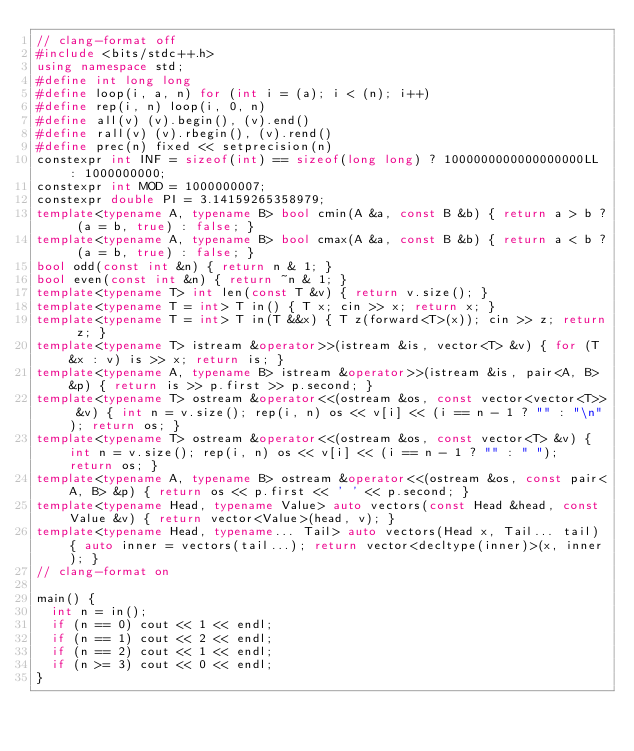Convert code to text. <code><loc_0><loc_0><loc_500><loc_500><_C++_>// clang-format off
#include <bits/stdc++.h>
using namespace std;
#define int long long
#define loop(i, a, n) for (int i = (a); i < (n); i++)
#define rep(i, n) loop(i, 0, n)
#define all(v) (v).begin(), (v).end()
#define rall(v) (v).rbegin(), (v).rend()
#define prec(n) fixed << setprecision(n)
constexpr int INF = sizeof(int) == sizeof(long long) ? 1000000000000000000LL : 1000000000;
constexpr int MOD = 1000000007;
constexpr double PI = 3.14159265358979;
template<typename A, typename B> bool cmin(A &a, const B &b) { return a > b ? (a = b, true) : false; }
template<typename A, typename B> bool cmax(A &a, const B &b) { return a < b ? (a = b, true) : false; }
bool odd(const int &n) { return n & 1; }
bool even(const int &n) { return ~n & 1; }
template<typename T> int len(const T &v) { return v.size(); }
template<typename T = int> T in() { T x; cin >> x; return x; }
template<typename T = int> T in(T &&x) { T z(forward<T>(x)); cin >> z; return z; }
template<typename T> istream &operator>>(istream &is, vector<T> &v) { for (T &x : v) is >> x; return is; }
template<typename A, typename B> istream &operator>>(istream &is, pair<A, B> &p) { return is >> p.first >> p.second; }
template<typename T> ostream &operator<<(ostream &os, const vector<vector<T>> &v) { int n = v.size(); rep(i, n) os << v[i] << (i == n - 1 ? "" : "\n"); return os; }
template<typename T> ostream &operator<<(ostream &os, const vector<T> &v) { int n = v.size(); rep(i, n) os << v[i] << (i == n - 1 ? "" : " "); return os; }
template<typename A, typename B> ostream &operator<<(ostream &os, const pair<A, B> &p) { return os << p.first << ' ' << p.second; }
template<typename Head, typename Value> auto vectors(const Head &head, const Value &v) { return vector<Value>(head, v); }
template<typename Head, typename... Tail> auto vectors(Head x, Tail... tail) { auto inner = vectors(tail...); return vector<decltype(inner)>(x, inner); }
// clang-format on

main() {
  int n = in();
  if (n == 0) cout << 1 << endl;
  if (n == 1) cout << 2 << endl;
  if (n == 2) cout << 1 << endl;
  if (n >= 3) cout << 0 << endl;
}

</code> 